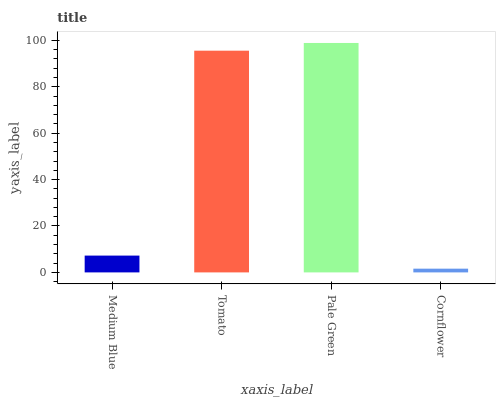Is Cornflower the minimum?
Answer yes or no. Yes. Is Pale Green the maximum?
Answer yes or no. Yes. Is Tomato the minimum?
Answer yes or no. No. Is Tomato the maximum?
Answer yes or no. No. Is Tomato greater than Medium Blue?
Answer yes or no. Yes. Is Medium Blue less than Tomato?
Answer yes or no. Yes. Is Medium Blue greater than Tomato?
Answer yes or no. No. Is Tomato less than Medium Blue?
Answer yes or no. No. Is Tomato the high median?
Answer yes or no. Yes. Is Medium Blue the low median?
Answer yes or no. Yes. Is Cornflower the high median?
Answer yes or no. No. Is Tomato the low median?
Answer yes or no. No. 